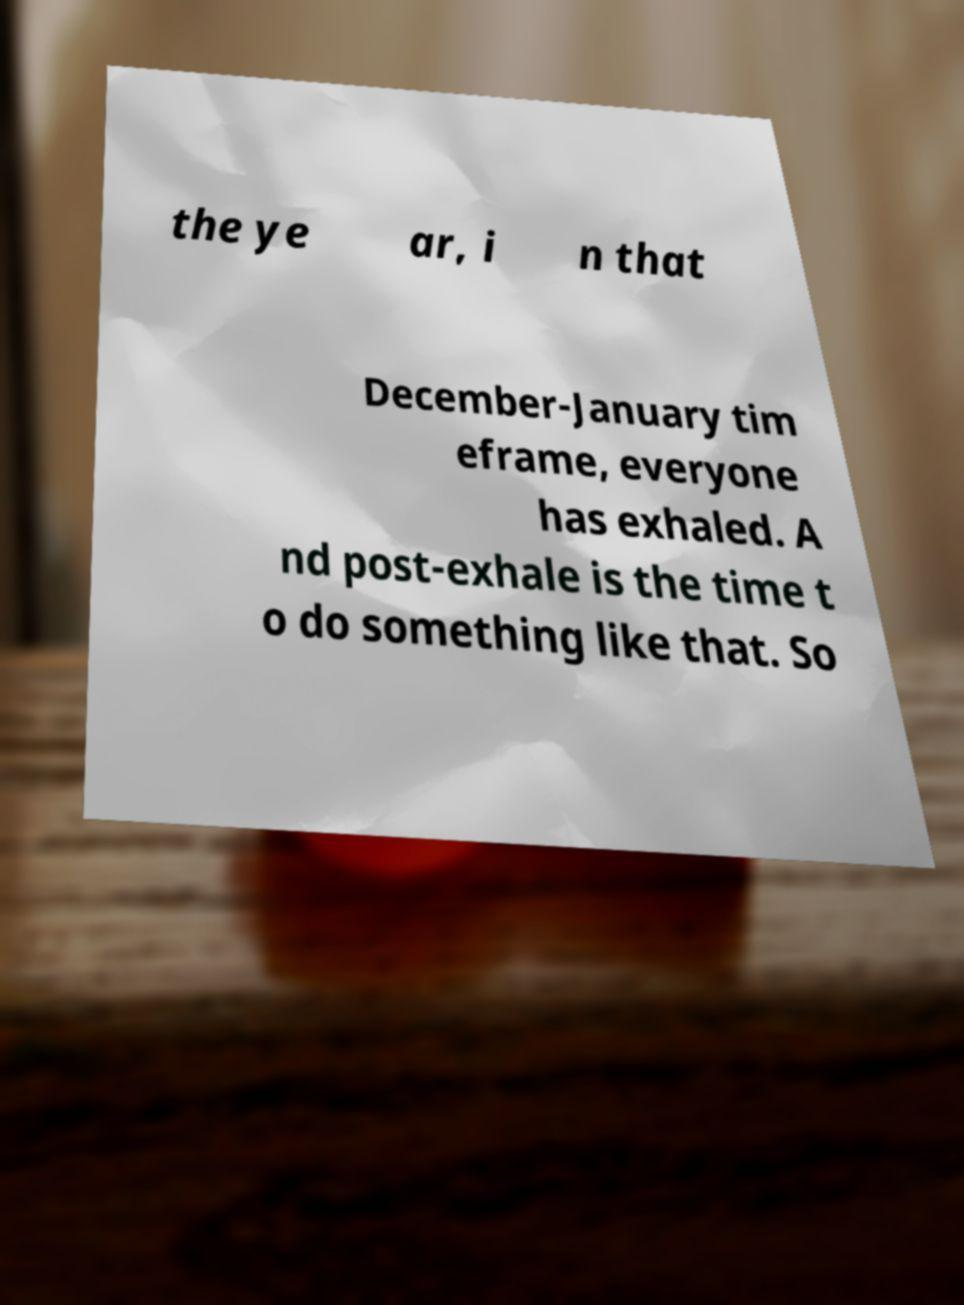Can you accurately transcribe the text from the provided image for me? the ye ar, i n that December-January tim eframe, everyone has exhaled. A nd post-exhale is the time t o do something like that. So 